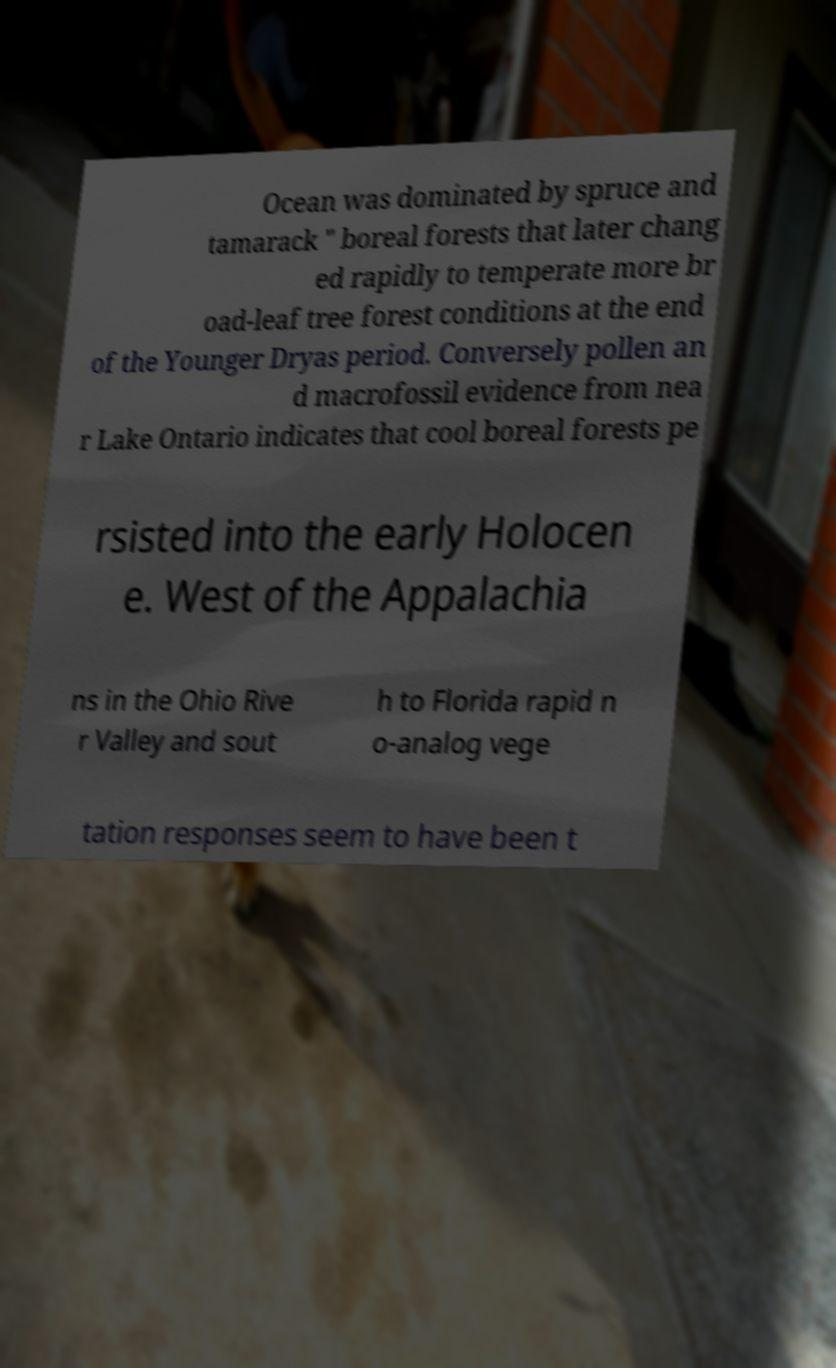Can you read and provide the text displayed in the image?This photo seems to have some interesting text. Can you extract and type it out for me? Ocean was dominated by spruce and tamarack " boreal forests that later chang ed rapidly to temperate more br oad-leaf tree forest conditions at the end of the Younger Dryas period. Conversely pollen an d macrofossil evidence from nea r Lake Ontario indicates that cool boreal forests pe rsisted into the early Holocen e. West of the Appalachia ns in the Ohio Rive r Valley and sout h to Florida rapid n o-analog vege tation responses seem to have been t 